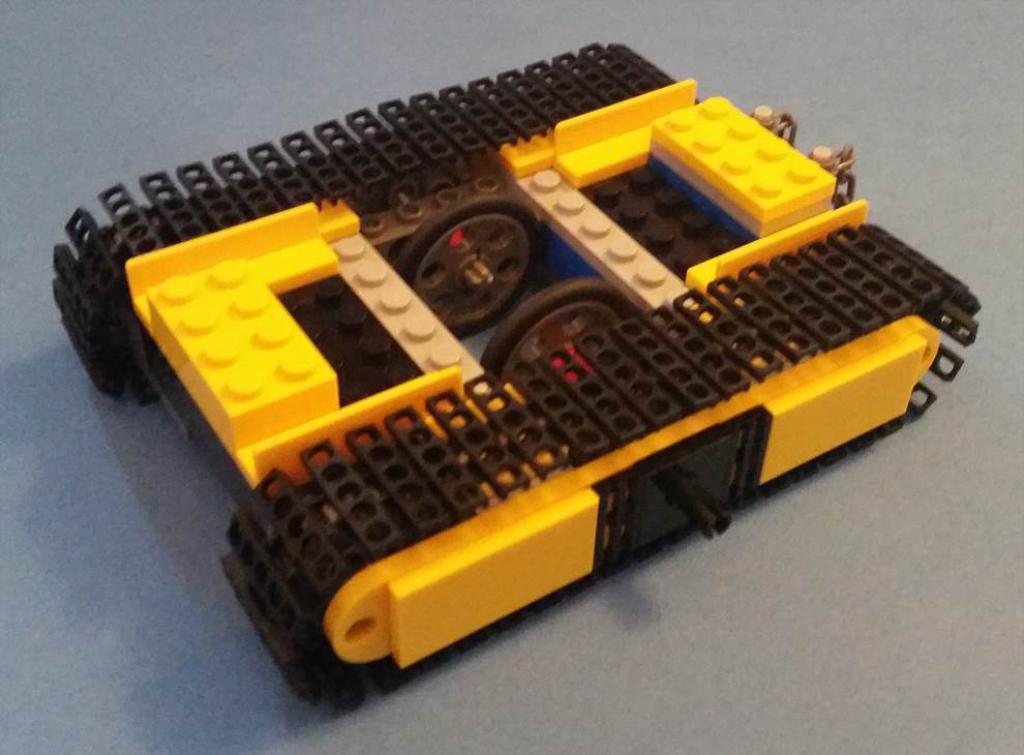Please provide a concise description of this image. In this image I can see the vehicle made of lego. It is on the ash color surface. 